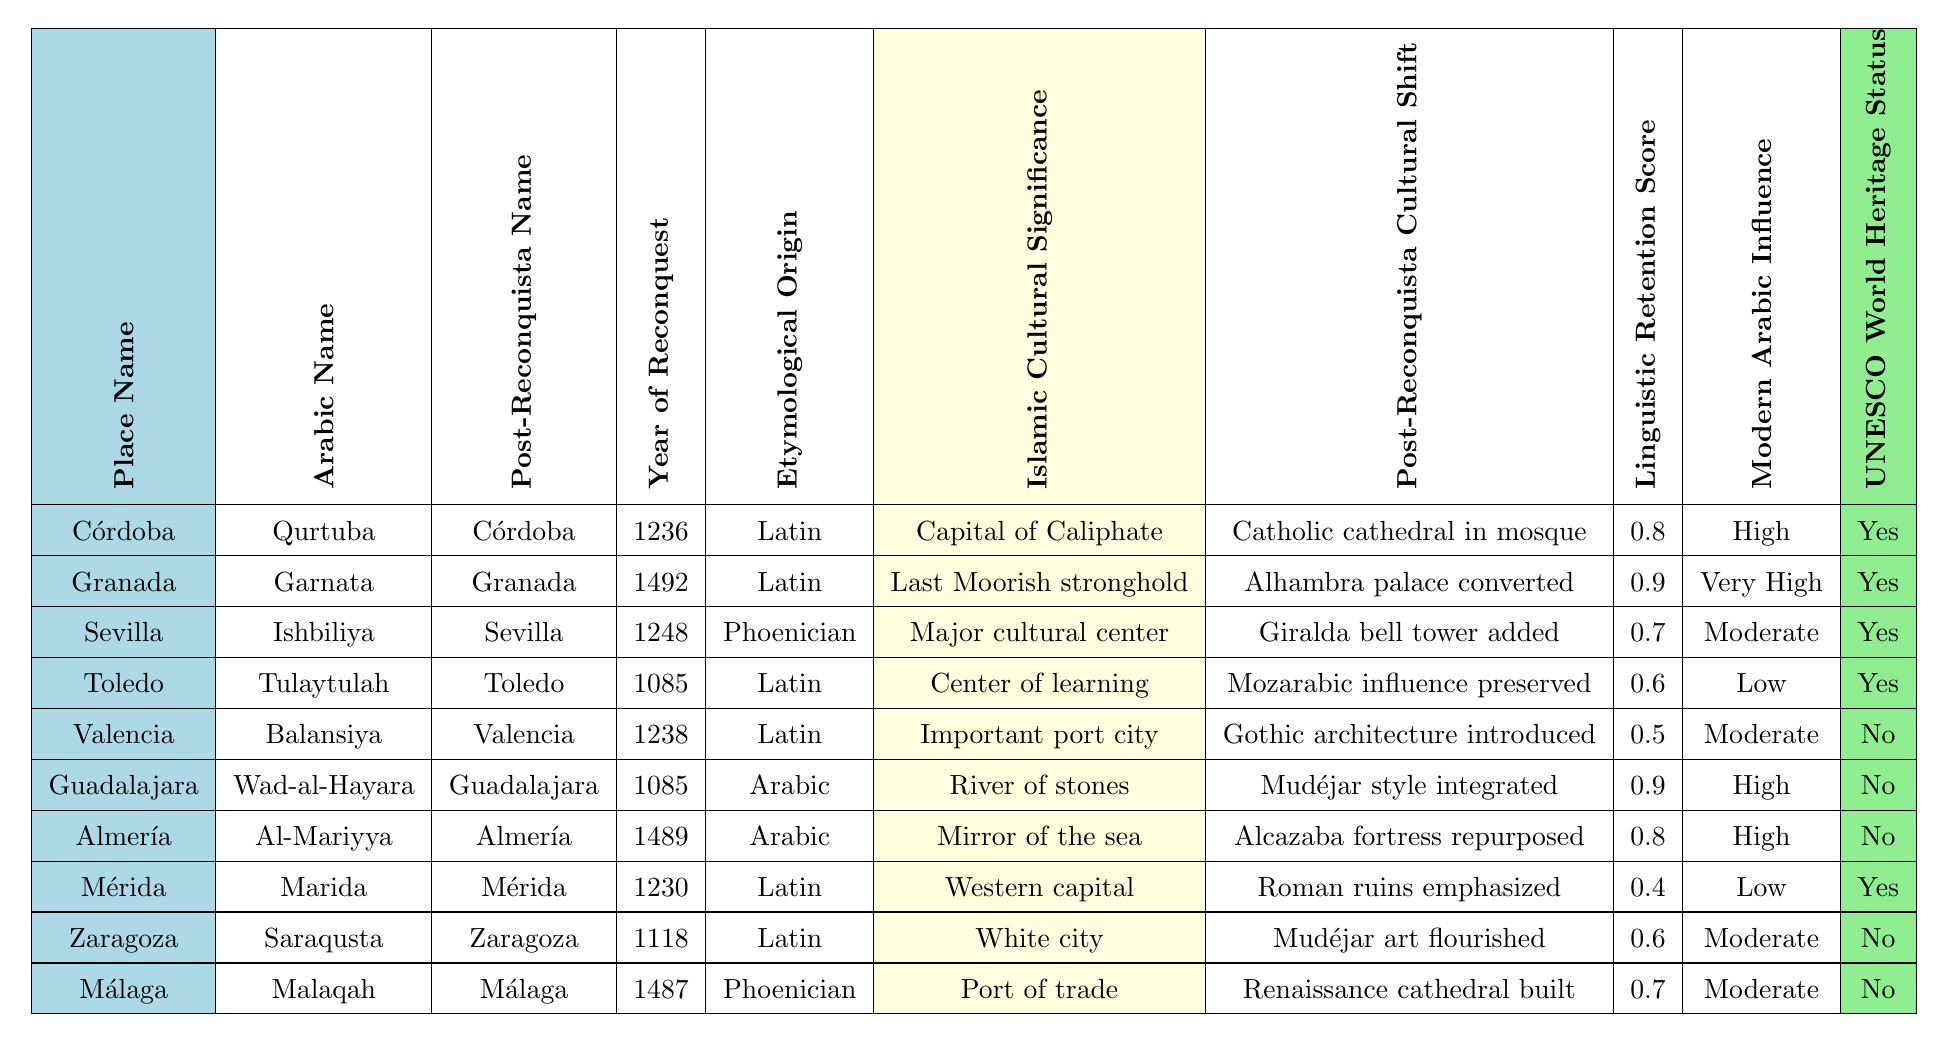What is the Arabic name for Córdoba? The table lists "Qurtuba" as the Arabic name corresponding to the place name "Córdoba."
Answer: Qurtuba In what year was Granada reconquered? The table shows that Granada was reconquered in the year 1492.
Answer: 1492 How many places have a UNESCO World Heritage Status? By counting the entries in the table, four places (Córdoba, Granada, Sevilla, and Mérida) have UNESCO World Heritage Status.
Answer: 4 Which place has the highest Linguistic Retention Score? The table indicates that both Guadalajara and Granada have the highest Linguistic Retention Score of 0.9.
Answer: Guadalajara and Granada What is the Islamic Cultural Significance of Málaga? The table indicates that the Islamic Cultural Significance of Málaga is "Port of trade."
Answer: Port of trade Which place has a Post-Reconquista Cultural Shift of "Gothic architecture introduced"? From the table, it is clear that Valencia underwent a "Gothic architecture introduced" cultural shift after the Reconquista.
Answer: Valencia What is the average Linguistic Retention Score for the places listed? Adding the Linguistic Retention Scores (0.8 + 0.9 + 0.7 + 0.6 + 0.5 + 0.9 + 0.8 + 0.4 + 0.6 + 0.7) totals 6.9. Dividing by 10 gives an average of 0.69.
Answer: 0.69 Is there a relationship between the Year of Reconquest and the Modern Arabic Influence? Analyzing the data shows a trend: places reconquered later (like Granada and Almería) have higher Modern Arabic Influence, suggesting an influence of time on cultural retention.
Answer: Yes, a general trend exists What was the linguistic origin of Guadalajara? The table states that the Etymological Origin of Guadalajara is "Arabic."
Answer: Arabic Which two cities have the same Post-Reconquista name as their Arabic name? The table shows that Córdoba and Granada have the same Post-Reconquista name as their Arabic name.
Answer: Córdoba and Granada 